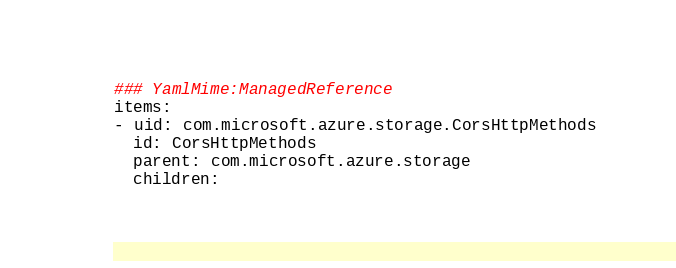<code> <loc_0><loc_0><loc_500><loc_500><_YAML_>### YamlMime:ManagedReference
items:
- uid: com.microsoft.azure.storage.CorsHttpMethods
  id: CorsHttpMethods
  parent: com.microsoft.azure.storage
  children:</code> 